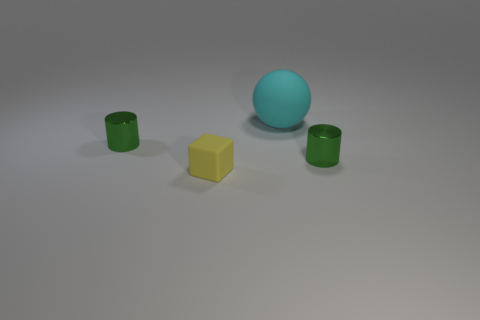Is there anything else that is the same size as the ball?
Make the answer very short. No. What number of other objects are the same size as the cyan rubber object?
Give a very brief answer. 0. Is there anything else that is the same shape as the small yellow object?
Give a very brief answer. No. What number of tiny yellow blocks are the same material as the big thing?
Your answer should be compact. 1. Is there a object left of the rubber thing behind the green metallic thing that is right of the tiny matte block?
Give a very brief answer. Yes. The yellow thing has what shape?
Your answer should be very brief. Cube. Does the small green object that is to the right of the large cyan matte sphere have the same material as the tiny green thing that is on the left side of the matte block?
Offer a very short reply. Yes. How many small cylinders are the same color as the large matte object?
Your answer should be compact. 0. What is the shape of the thing that is behind the small matte thing and on the left side of the big rubber thing?
Keep it short and to the point. Cylinder. There is a tiny thing that is both left of the sphere and behind the tiny yellow object; what is its color?
Keep it short and to the point. Green. 